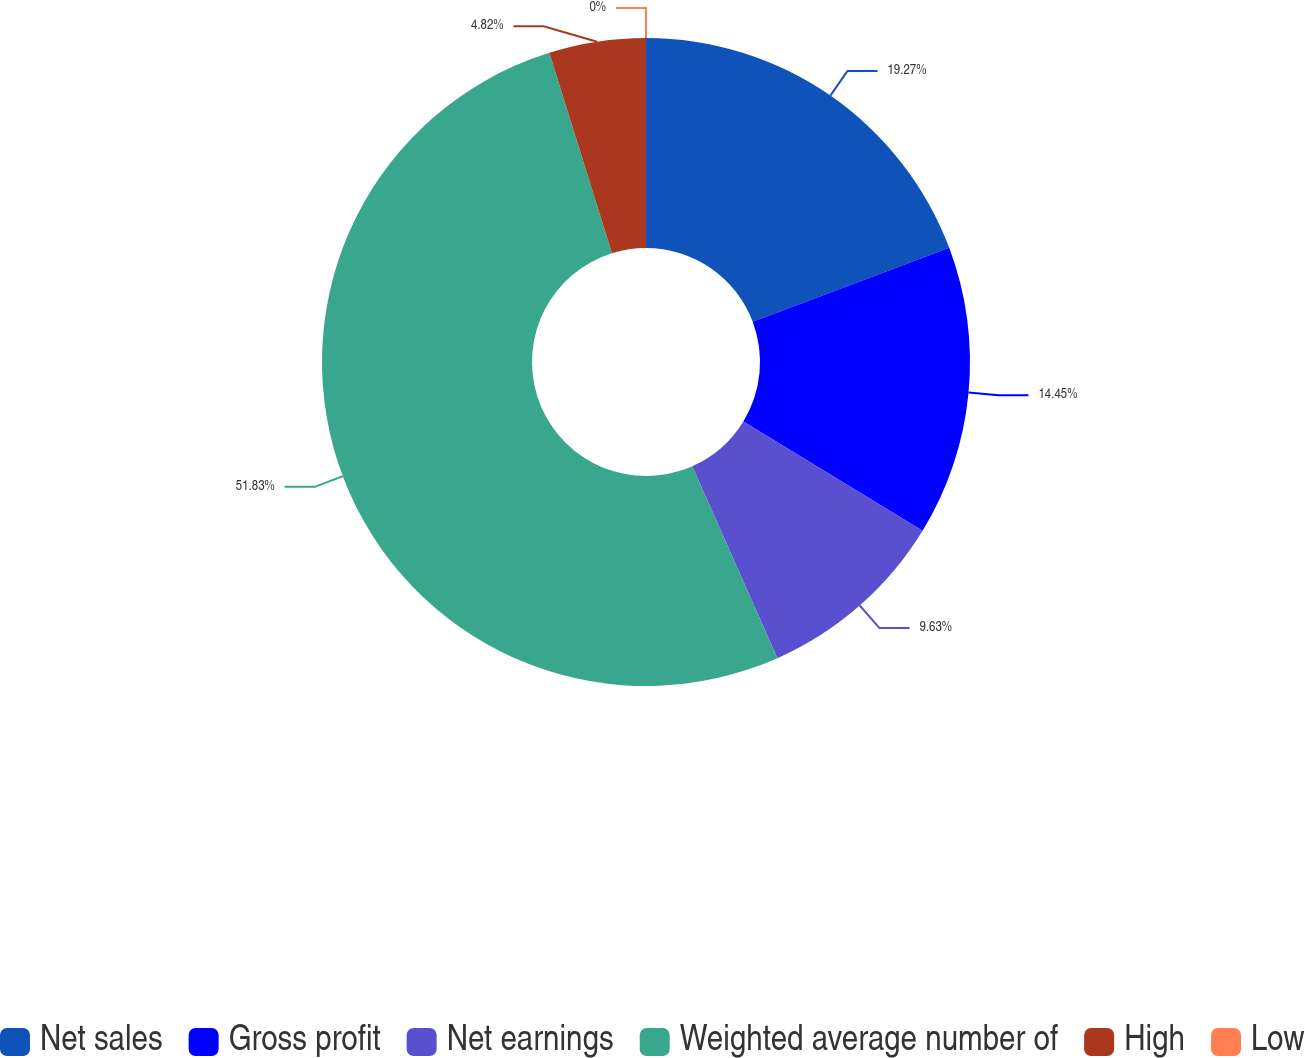<chart> <loc_0><loc_0><loc_500><loc_500><pie_chart><fcel>Net sales<fcel>Gross profit<fcel>Net earnings<fcel>Weighted average number of<fcel>High<fcel>Low<nl><fcel>19.27%<fcel>14.45%<fcel>9.63%<fcel>51.83%<fcel>4.82%<fcel>0.0%<nl></chart> 